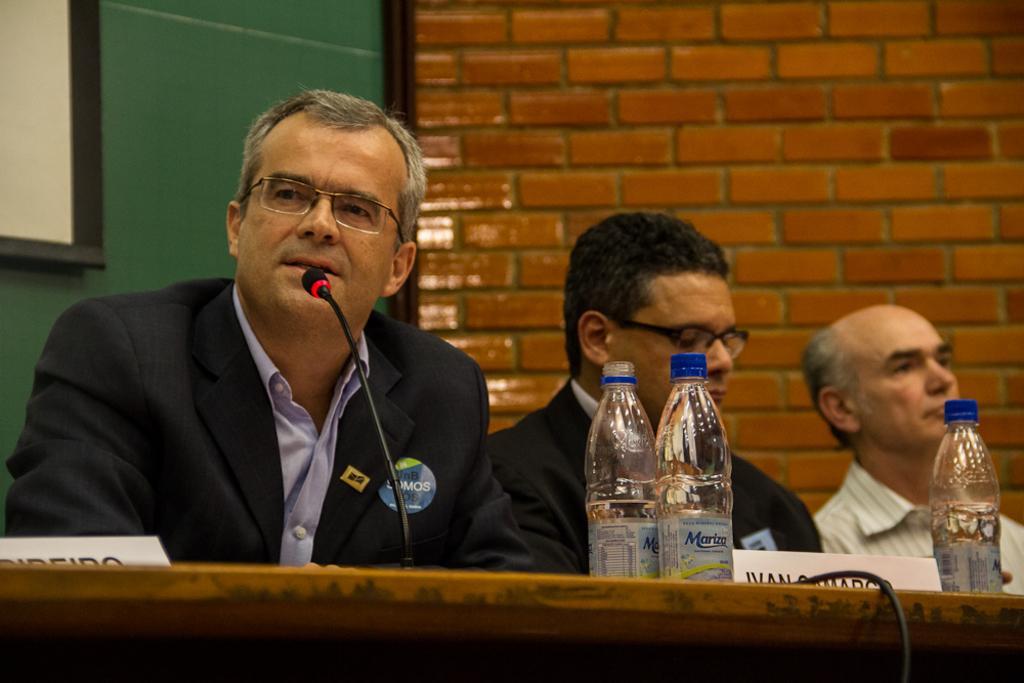Please provide a concise description of this image. In the image we can see three persons were sitting. In front we can see table,on table we can see microphone,three bottles etc. And back there is a notice board and brick wall. 